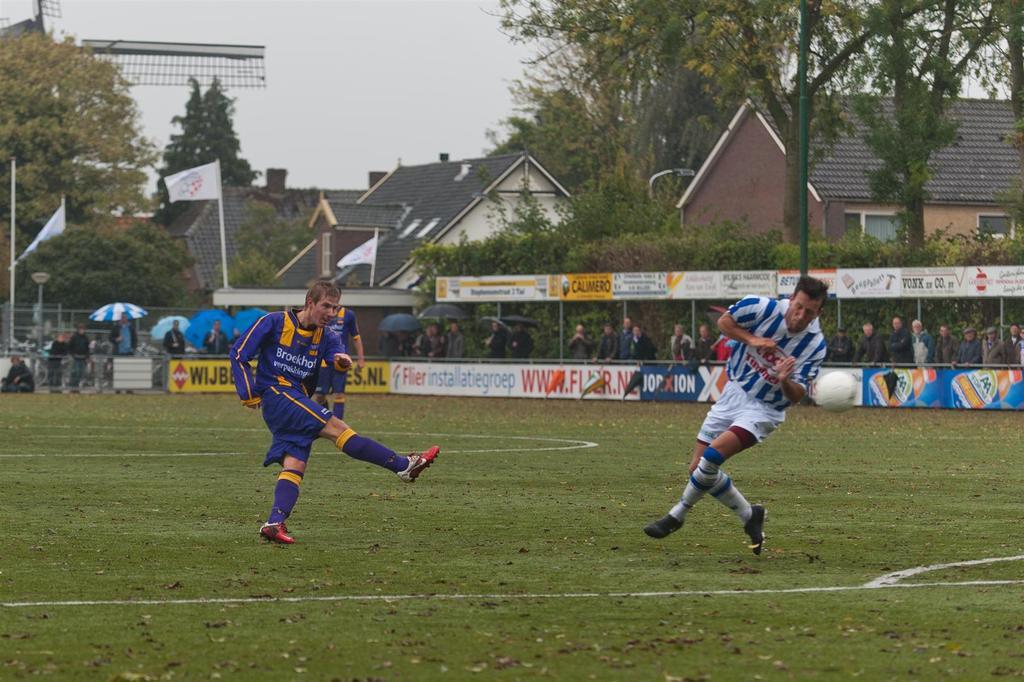Name one sponsor from the photo?
Offer a very short reply. Unanswerable. What is the first letter of the name on the blue jersey?
Ensure brevity in your answer.  B. 